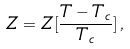Convert formula to latex. <formula><loc_0><loc_0><loc_500><loc_500>Z = Z [ \frac { T - T _ { c } } { T _ { c } } ] \, ,</formula> 